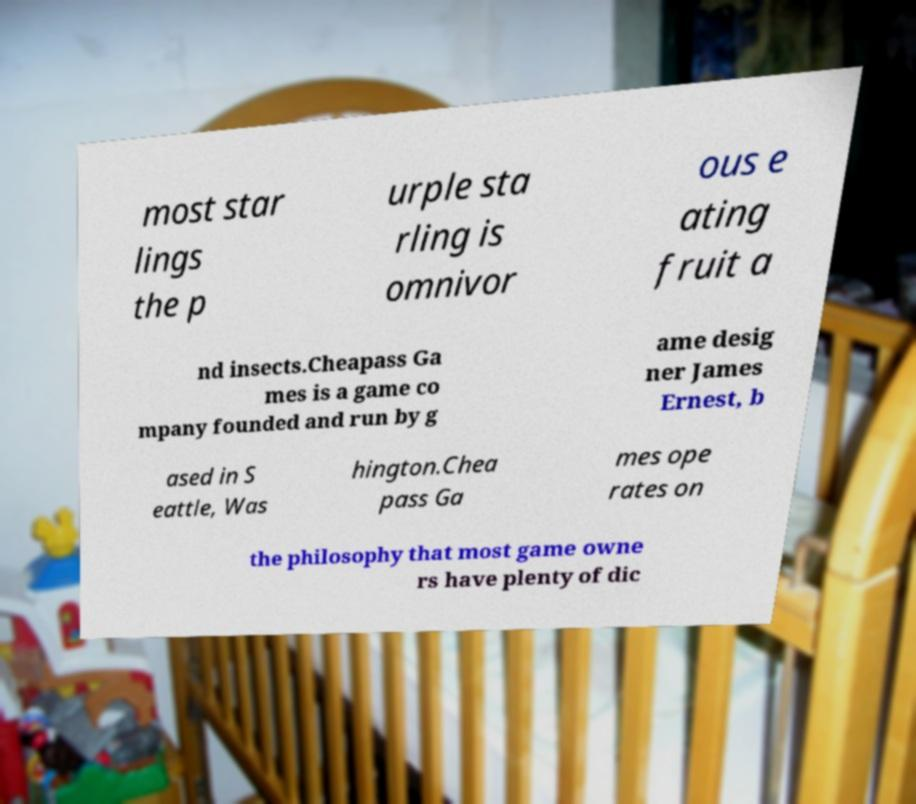There's text embedded in this image that I need extracted. Can you transcribe it verbatim? most star lings the p urple sta rling is omnivor ous e ating fruit a nd insects.Cheapass Ga mes is a game co mpany founded and run by g ame desig ner James Ernest, b ased in S eattle, Was hington.Chea pass Ga mes ope rates on the philosophy that most game owne rs have plenty of dic 